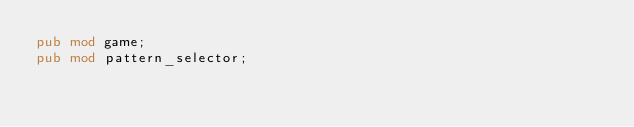<code> <loc_0><loc_0><loc_500><loc_500><_Rust_>pub mod game;
pub mod pattern_selector;
</code> 